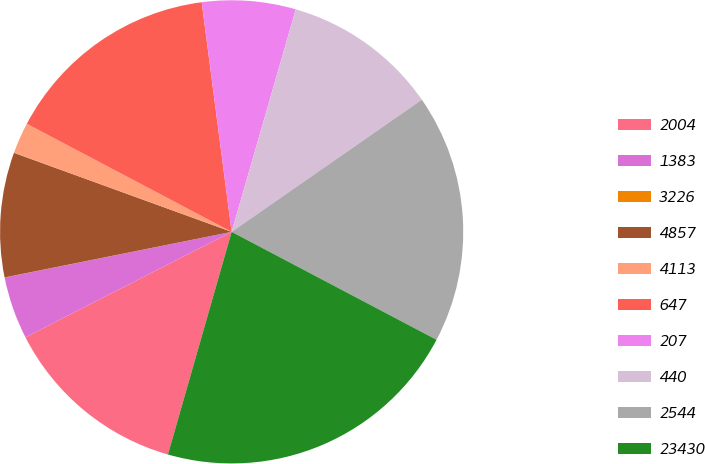<chart> <loc_0><loc_0><loc_500><loc_500><pie_chart><fcel>2004<fcel>1383<fcel>3226<fcel>4857<fcel>4113<fcel>647<fcel>207<fcel>440<fcel>2544<fcel>23430<nl><fcel>13.04%<fcel>4.36%<fcel>0.01%<fcel>8.7%<fcel>2.18%<fcel>15.21%<fcel>6.53%<fcel>10.87%<fcel>17.38%<fcel>21.72%<nl></chart> 